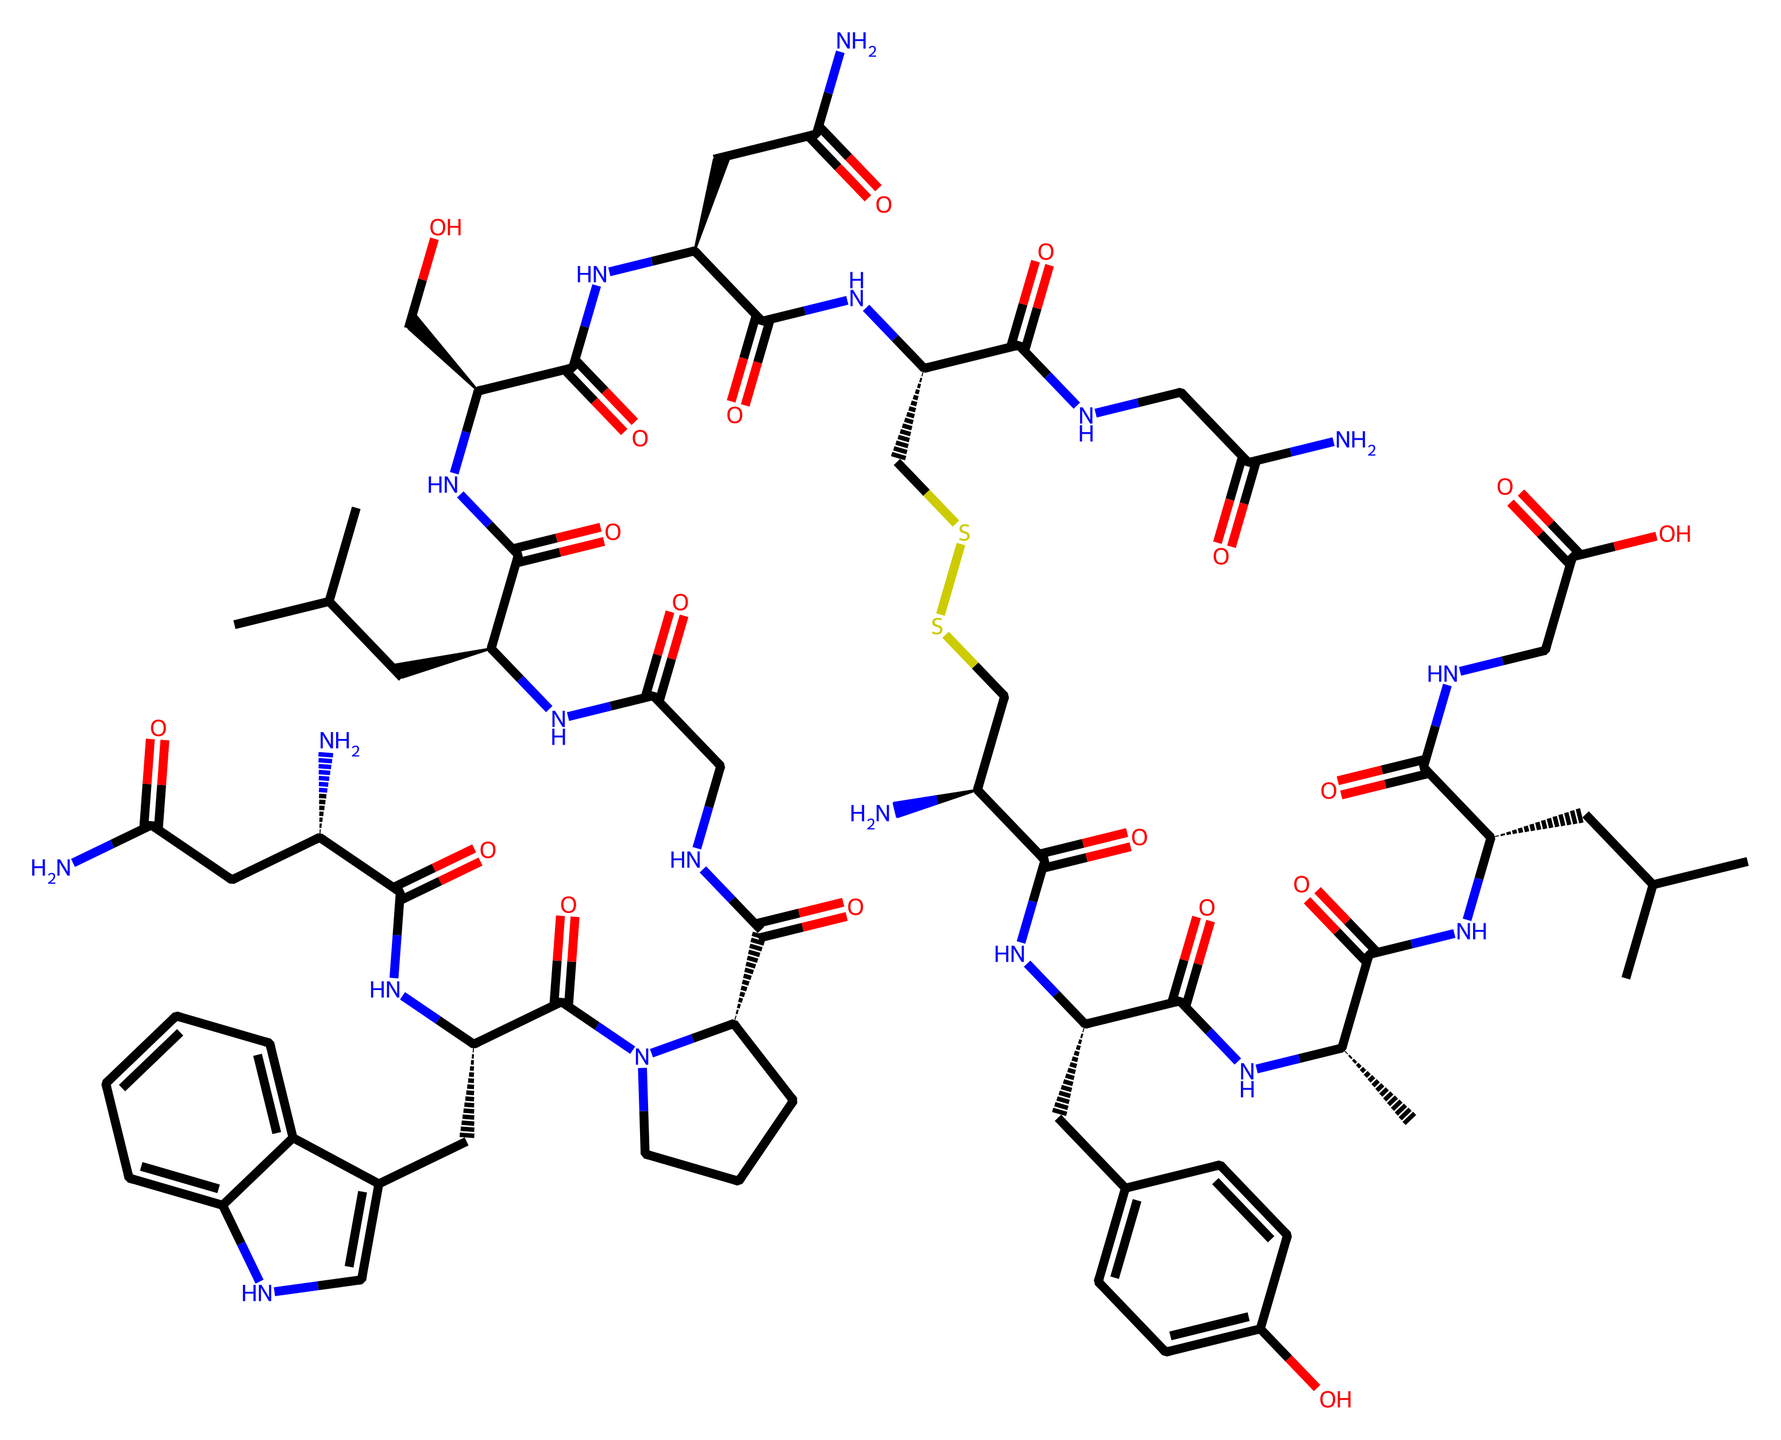what is the molecular formula of this chemical? To determine the molecular formula, count each type of atom in the SMILES representation. This involves identifying all carbon (C), hydrogen (H), nitrogen (N), oxygen (O), and sulfur (S) atoms represented. After counting, we find there are 54 carbon atoms, 70 hydrogen atoms, 10 nitrogen atoms, 13 oxygen atoms, and 2 sulfur atoms. Thus, the molecular formula is C54H70N10O13S2.
Answer: C54H70N10O13S2 how many nitrogen atoms are present in this molecule? By carefully examining the SMILES notation, locate each instance of the letter "N," which represents nitrogen atoms in the structure. Counting these results in a total of 10 nitrogen atoms.
Answer: 10 what is the number of disulfide bonds observed? The presence of a disulfide bond can be deduced from the indication of "SS" in the SMILES representation, signifying a bond between two sulfur atoms. In this case, there is only one occurrence of "SS," indicating one disulfide bond in the structure.
Answer: 1 how many carbon rings are present in this molecule? To assess the presence of carbon rings, look for the numbers in the SMILES notation, which indicate starting and closing points of rings. The "c" and "C" denote carbon atoms involved in aromatic and aliphatic structures. Analyzing this, we find two rings: one in the "Cc2c[nH]c3ccccc23" section and another in "Cc1ccc(O)cc1." Therefore, the total number of rings is 2.
Answer: 2 does this chemical contain hydroxyl (-OH) groups? Hydroxyl groups are indicated by "O" followed by a carbon symbol in the structure. Scanning the SMILES notation, we can observe the presence of "O" connected to "c" which is representative of an aromatic contribute. Specifically, there is one hydroxyl mentioned in the "Cc1ccc(O)cc1" part of the SMILES. There is therefore one hydroxyl group present.
Answer: 1 what is the most likely functional group associated with this compound? The compound is likely to contain amide functional groups, which is indicated by the repeating "NC(=O)" structures in the SMILES. This observation, combined with the molecular connectivity, suggests that amide functional groups are prominent throughout the molecule. Thus, the most likely functional group is amide.
Answer: amide 